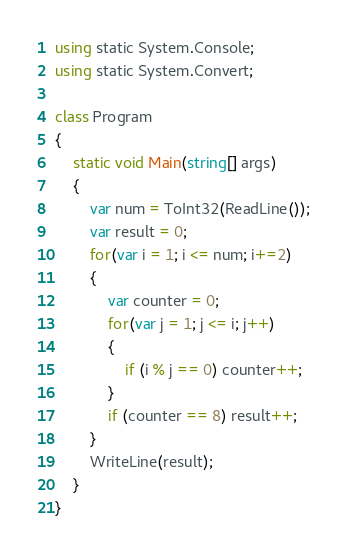<code> <loc_0><loc_0><loc_500><loc_500><_C#_>using static System.Console;
using static System.Convert;

class Program
{
    static void Main(string[] args)
    {
        var num = ToInt32(ReadLine());
        var result = 0;
        for(var i = 1; i <= num; i+=2)
        {
            var counter = 0;
            for(var j = 1; j <= i; j++)
            {
                if (i % j == 0) counter++;
            }
            if (counter == 8) result++;
        }
        WriteLine(result);
    }
}

</code> 